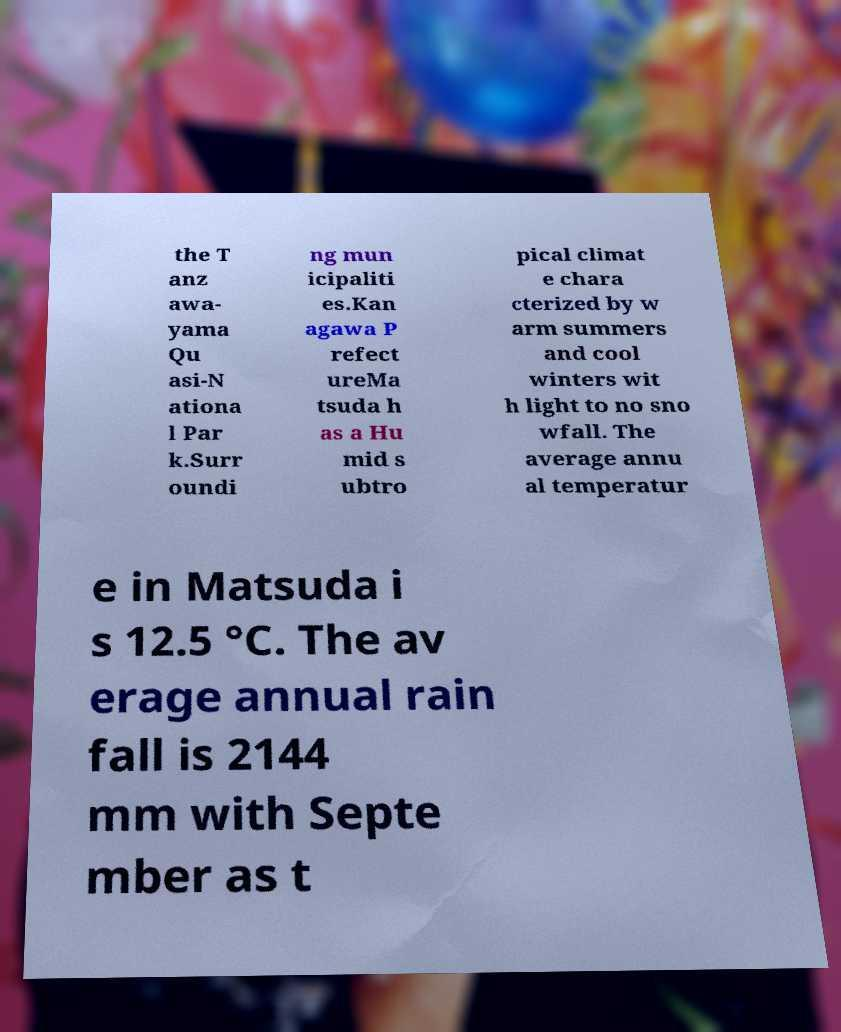What messages or text are displayed in this image? I need them in a readable, typed format. the T anz awa- yama Qu asi-N ationa l Par k.Surr oundi ng mun icipaliti es.Kan agawa P refect ureMa tsuda h as a Hu mid s ubtro pical climat e chara cterized by w arm summers and cool winters wit h light to no sno wfall. The average annu al temperatur e in Matsuda i s 12.5 °C. The av erage annual rain fall is 2144 mm with Septe mber as t 